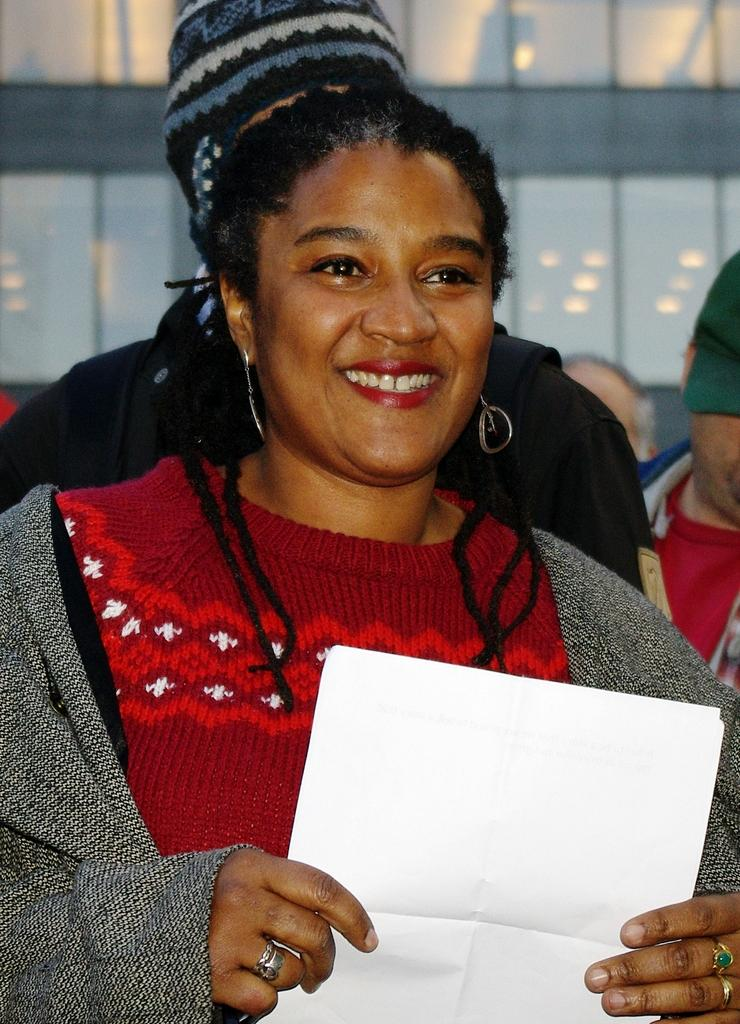Who is the main subject in the image? There is a woman in the image. What is the woman wearing? The woman is wearing a gray jacket. What is the woman holding in the image? The woman is holding papers. What can be seen in the background of the image? There are many people and a building visible in the background of the image. What type of tub is visible in the image? There is no tub present in the image. Is the woman wearing a mask in the image? The woman is not wearing a mask in the image. 